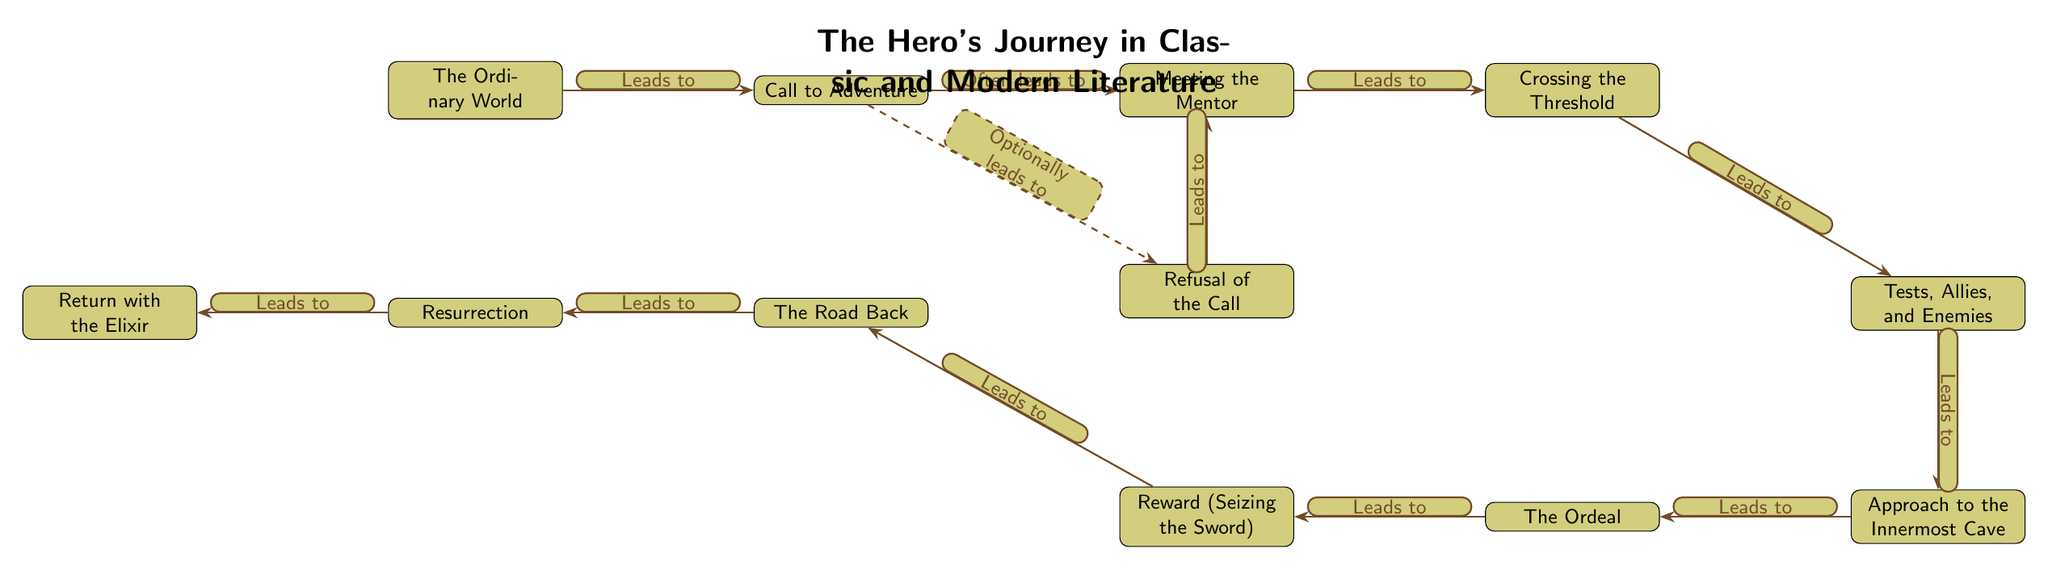What is the first step in the Hero's Journey? The first node in the diagram represents "The Ordinary World," indicating that this is the initial stage of the Hero's Journey.
Answer: The Ordinary World How many nodes are present in the diagram? To determine the number of nodes, we count each labeled stage from "The Ordinary World" down to "Return with the Elixir." There are twelve nodes in total.
Answer: 12 What stage directly follows "Meeting the Mentor"? In the diagram, "Crossing the Threshold" is positioned immediately to the right of "Meeting the Mentor," showing that it is the direct next step.
Answer: Crossing the Threshold Which stage is often an optional part of the journey? The stage labeled "Refusal of the Call" has a dashed line connecting it to the "Call to Adventure," signifying that it is an optional part that a hero may or may not experience.
Answer: Refusal of the Call What leads to the "The Road Back"? According to the flow of the diagram, "Reward (Seizing the Sword)" is the node that leads into "The Road Back," making it the preceding stage.
Answer: Reward (Seizing the Sword) How does "The Ordeal" connect to the Hero's Journey? The diagram shows "The Ordeal" leading to "Reward (Seizing the Sword)," indicating that after facing the main challenge, the hero receives a reward.
Answer: Leads to Reward (Seizing the Sword) What relationship does the "Call to Adventure" have with "Meeting the Mentor"? The diagram states that the "Call to Adventure" often leads to "Meeting the Mentor," highlighting an essential mentorship component following the call.
Answer: Often leads to What is the last step of the Hero's Journey structure? The final node in the diagram is "Return with the Elixir," which signifies the conclusion of the Hero's Journey.
Answer: Return with the Elixir Which two stages are positioned below "Tests, Allies, and Enemies"? The diagram reflects that "Approach to the Innermost Cave" is directly below "Tests, Allies, and Enemies," while the subsequent node below that is "The Ordeal."
Answer: Approach to the Innermost Cave and The Ordeal 